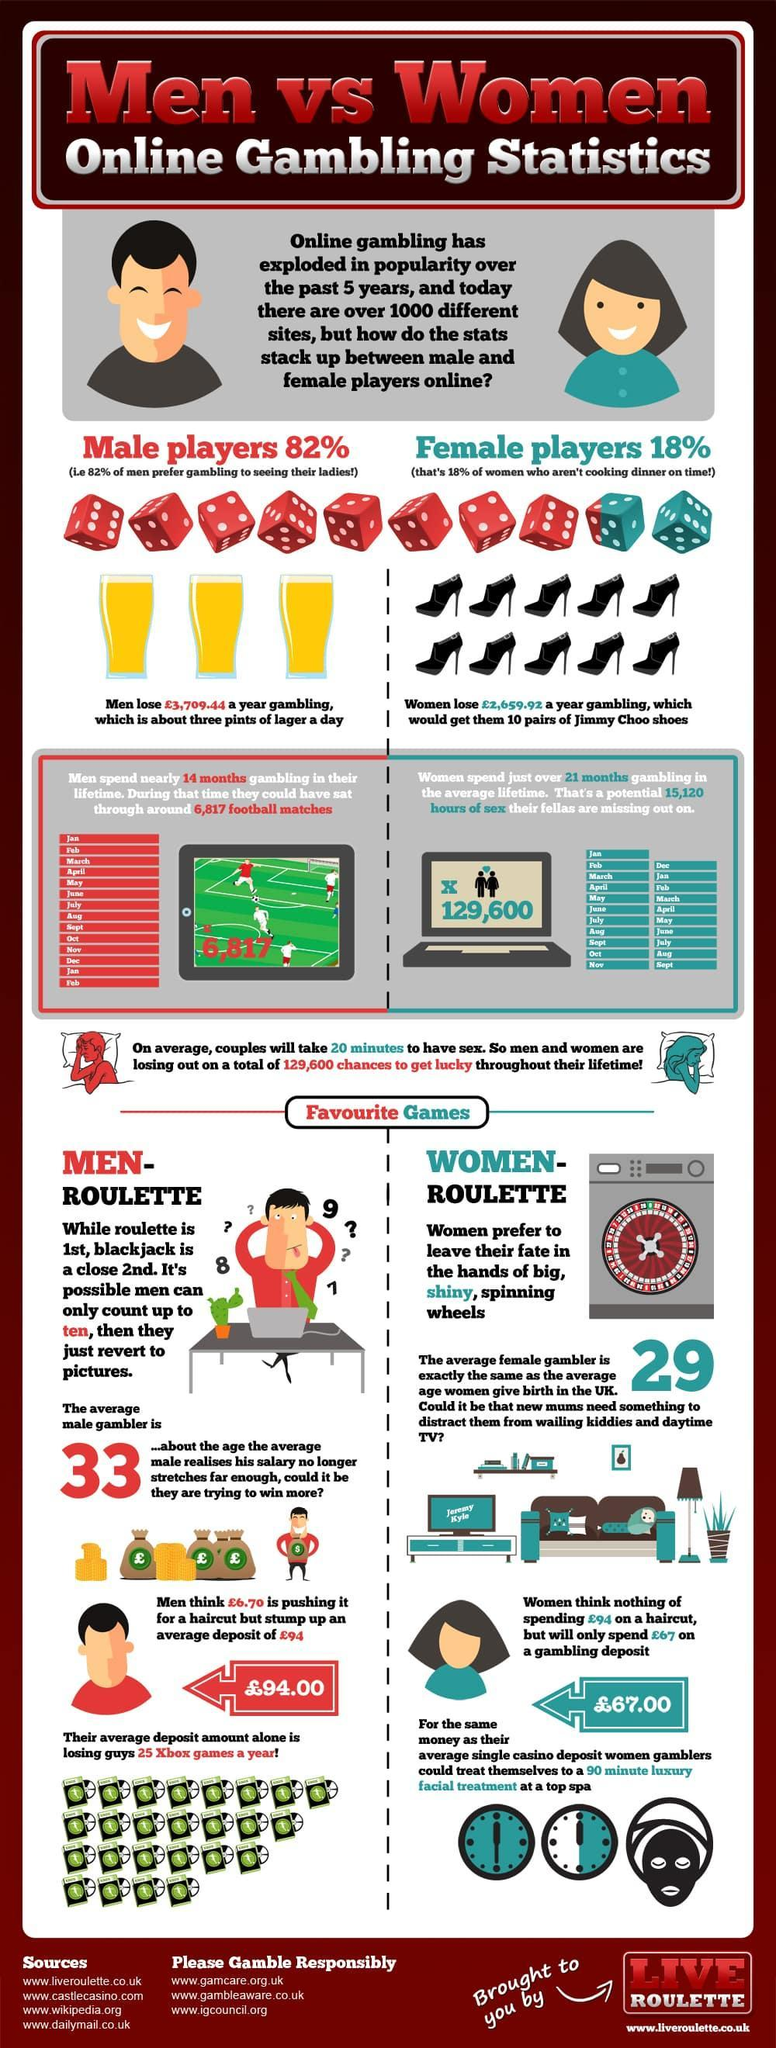How many dice are in this infographic?
Answer the question with a short phrase. 10 How many clocks are in this infographic? 2 